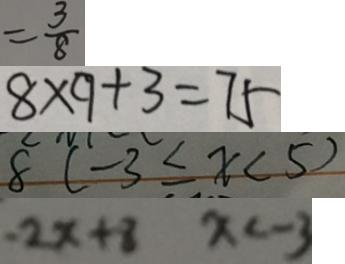<formula> <loc_0><loc_0><loc_500><loc_500>= \frac { 3 } { 8 } 
 8 \times 9 + 3 = 7 5 
 8 ( - 3 \leq x < 5 ) 
 - 2 x + 8 x < - 3</formula> 